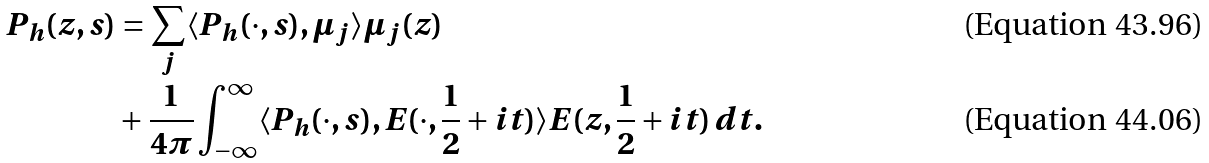Convert formula to latex. <formula><loc_0><loc_0><loc_500><loc_500>P _ { h } ( z , s ) & = \sum _ { j } \langle P _ { h } ( \cdot , s ) , \mu _ { j } \rangle \mu _ { j } ( z ) \\ & + \frac { 1 } { 4 \pi } \int _ { - \infty } ^ { \infty } \langle P _ { h } ( \cdot , s ) , E ( \cdot , \frac { 1 } { 2 } + i t ) \rangle E ( z , \frac { 1 } { 2 } + i t ) \, d t .</formula> 